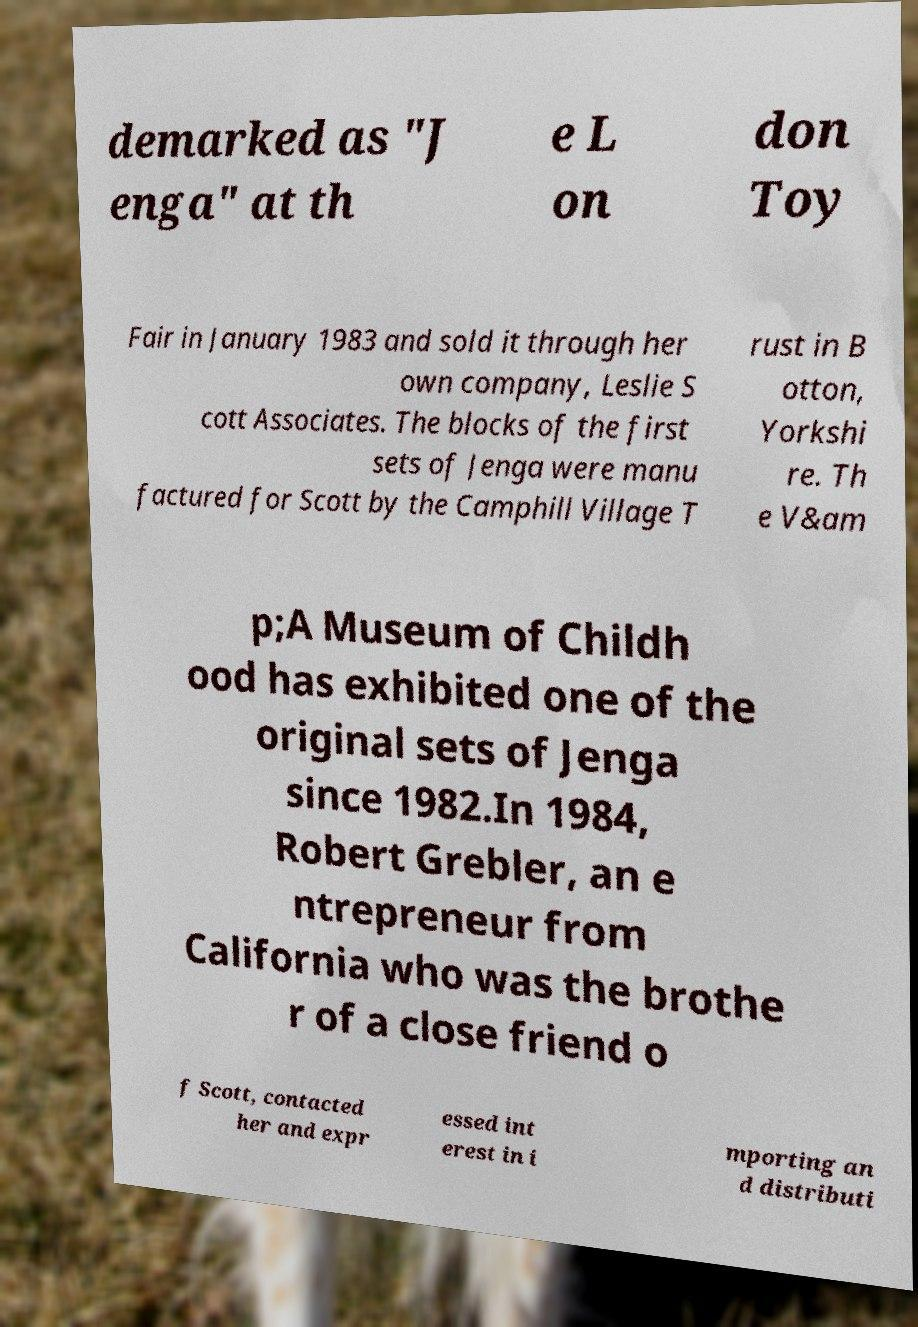Could you assist in decoding the text presented in this image and type it out clearly? demarked as "J enga" at th e L on don Toy Fair in January 1983 and sold it through her own company, Leslie S cott Associates. The blocks of the first sets of Jenga were manu factured for Scott by the Camphill Village T rust in B otton, Yorkshi re. Th e V&am p;A Museum of Childh ood has exhibited one of the original sets of Jenga since 1982.In 1984, Robert Grebler, an e ntrepreneur from California who was the brothe r of a close friend o f Scott, contacted her and expr essed int erest in i mporting an d distributi 